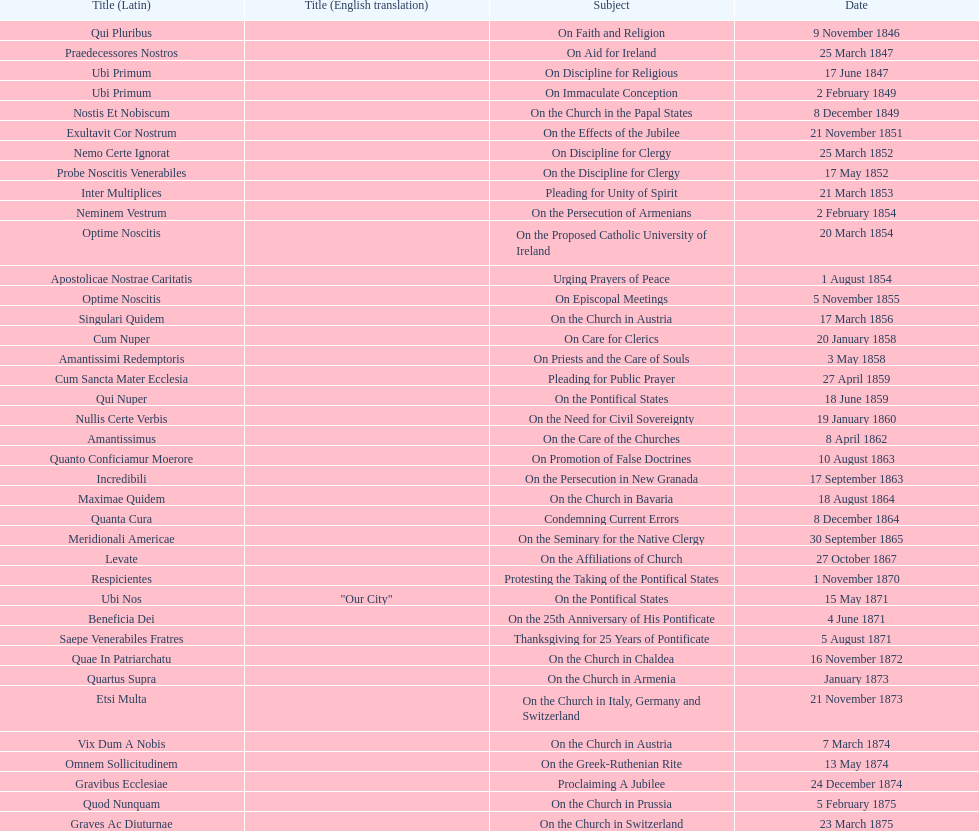How many encyclicals were issued between august 15, 1854 and october 26, 1867? 13. 